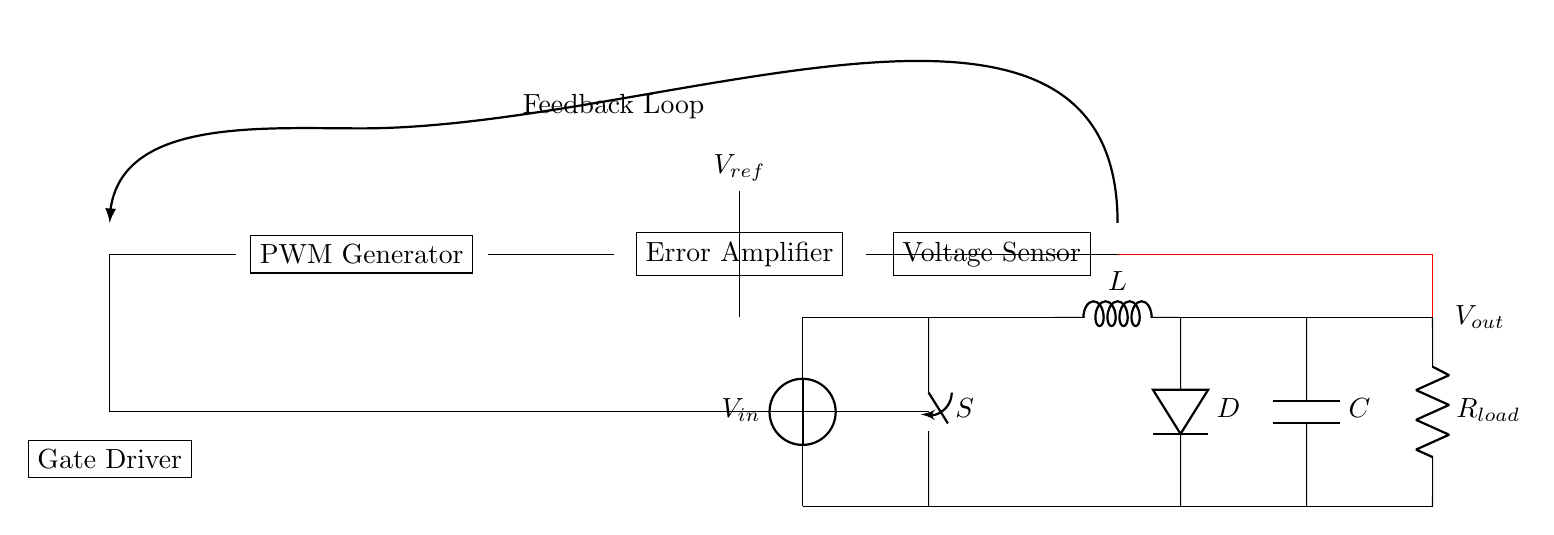What is the input voltage represented in the circuit? The input voltage is shown at the source labeled \(V_{in}\) in the circuit diagram, which implies it is the supply voltage for the DC-DC converter.
Answer: \(V_{in}\) What component regulates the output voltage? The component responsible for regulating the output voltage is the error amplifier, which compares the actual output voltage with the reference voltage \(V_{ref}\) to adjust the control signals.
Answer: Error Amplifier What does the PWM generator do in this circuit? The PWM generator converts the control signal from the error amplifier into a pulse-width modulation signal to regulate the on/off switching of the converter, affecting the output voltage.
Answer: Generate PWM signal What is the purpose of the feedback loop in this closed-loop control system? The feedback loop continuously monitors the output voltage, sending it back to the error amplifier for comparison with the reference voltage, allowing the system to adjust the PWM signal as needed to maintain stable regulation.
Answer: Maintain voltage regulation What component is used to drive the switch? The component that drives the switch \(S\) is the gate driver, which applies the appropriate signal to control the opening and closing of the switch based on the PWM signal.
Answer: Gate Driver How is the output voltage sensed in the circuit? The output voltage is sensed by the voltage sensor, which takes a measurement of \(V_{out}\) and feeds it back to the error amplifier for comparison with \(V_{ref}\).
Answer: Voltage Sensor 